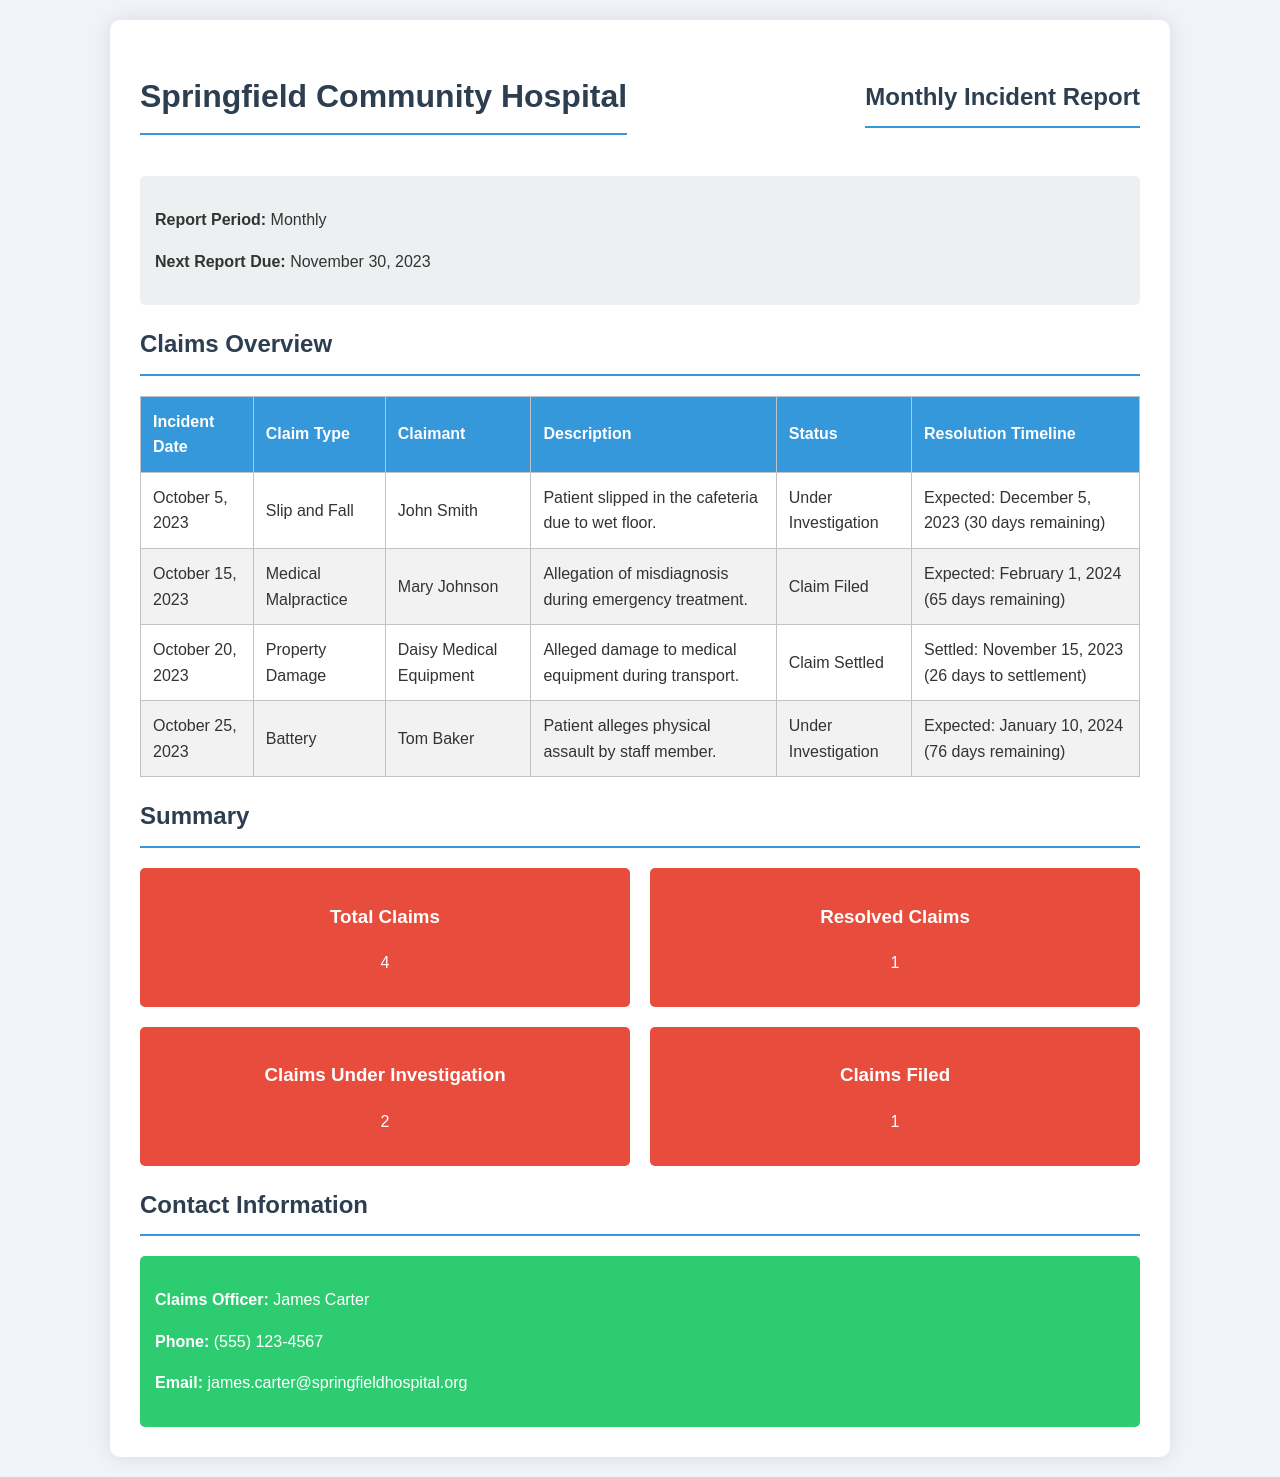what is the report period? The report period is indicated at the beginning of the document, which specifies the frequency of the report.
Answer: Monthly what is the next report due date? The document states the next report due date clearly under the report information section.
Answer: November 30, 2023 how many total claims are there? The total claims can be found in the summary section of the document, which aggregates all reported incidents.
Answer: 4 who is the claims officer? The claims officer's name is listed in the contact information section of the document.
Answer: James Carter what is the status of the claim from October 5, 2023? The status is provided next to the respective claim in the claims table, showing the current investigation stage.
Answer: Under Investigation how many claims are currently under investigation? This number is summarized clearly in the claims summary section, indicating the total counts of each claim status.
Answer: 2 what type of claim was made on October 20, 2023? The claim type is detailed in the claims table for the corresponding date, showing the nature of the incident.
Answer: Property Damage what is the expected resolution date for the claim filed by Mary Johnson? The expected resolution date is mentioned next to her claim in the claims table, giving insight into the timeline.
Answer: February 1, 2024 how many claims have been settled? The number of resolved claims is provided as part of the summary in the document, specifically highlighting settled cases.
Answer: 1 